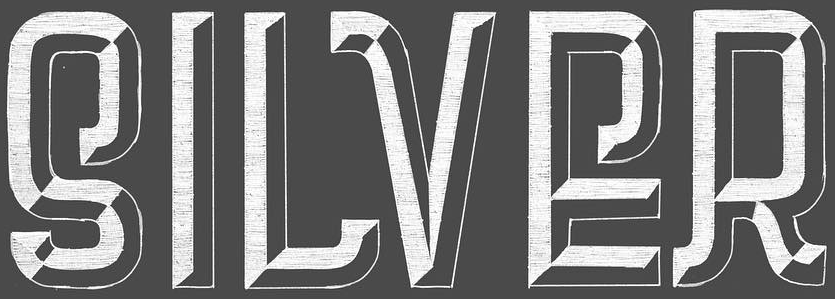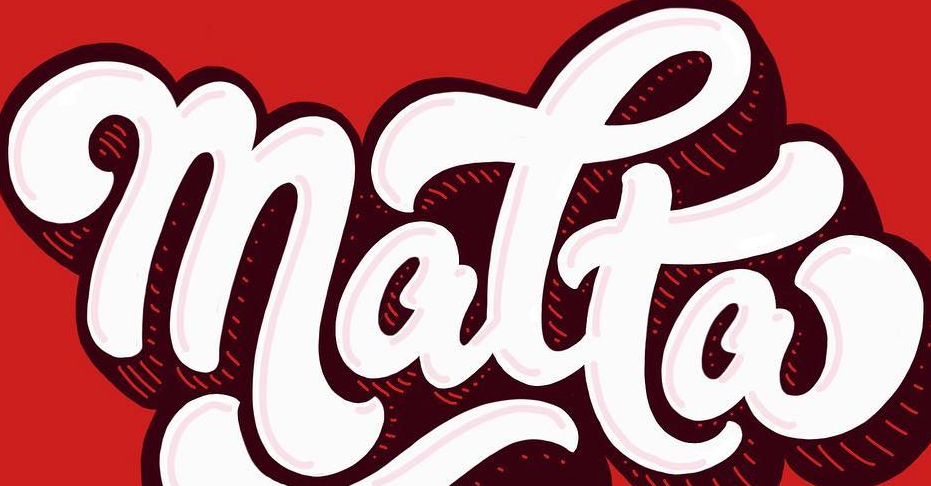Read the text from these images in sequence, separated by a semicolon. SILVER; matta 